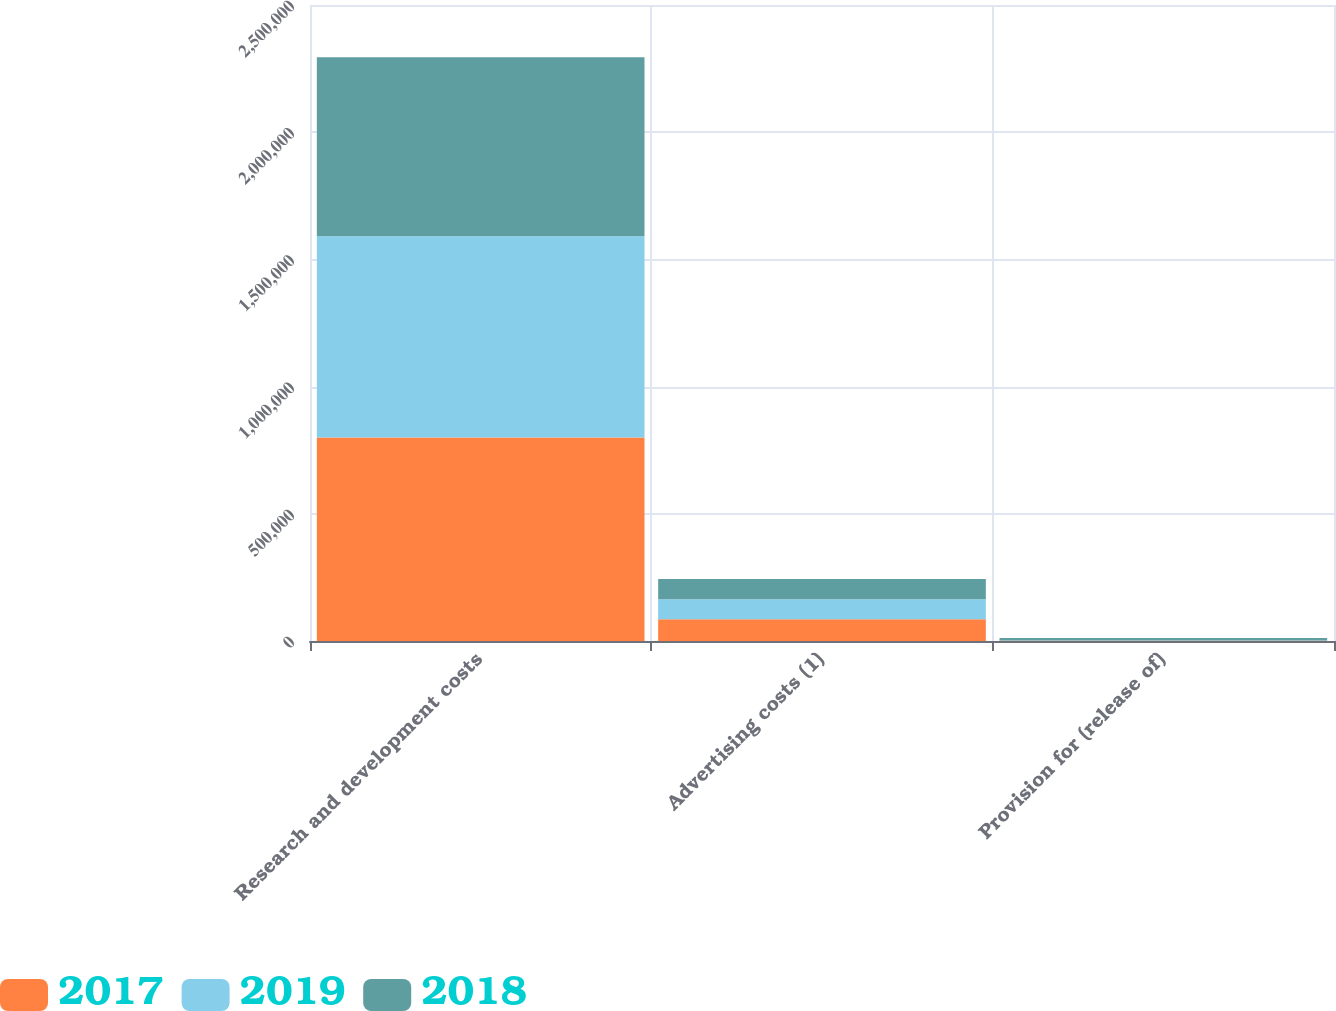Convert chart to OTSL. <chart><loc_0><loc_0><loc_500><loc_500><stacked_bar_chart><ecel><fcel>Research and development costs<fcel>Advertising costs (1)<fcel>Provision for (release of)<nl><fcel>2017<fcel>799734<fcel>85521<fcel>974<nl><fcel>2019<fcel>790779<fcel>78464<fcel>1060<nl><fcel>2018<fcel>704317<fcel>79883<fcel>10117<nl></chart> 